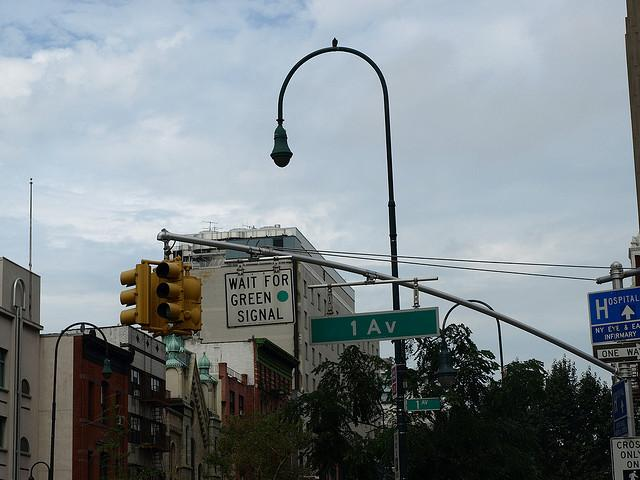What kind of environment is this? urban 